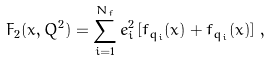Convert formula to latex. <formula><loc_0><loc_0><loc_500><loc_500>F _ { 2 } ( x , Q ^ { 2 } ) = \sum _ { i = 1 } ^ { N _ { f } } e _ { i } ^ { 2 } \left [ f _ { q _ { i } } ( x ) + f _ { \bar { q } _ { i } } ( x ) \right ] \, ,</formula> 